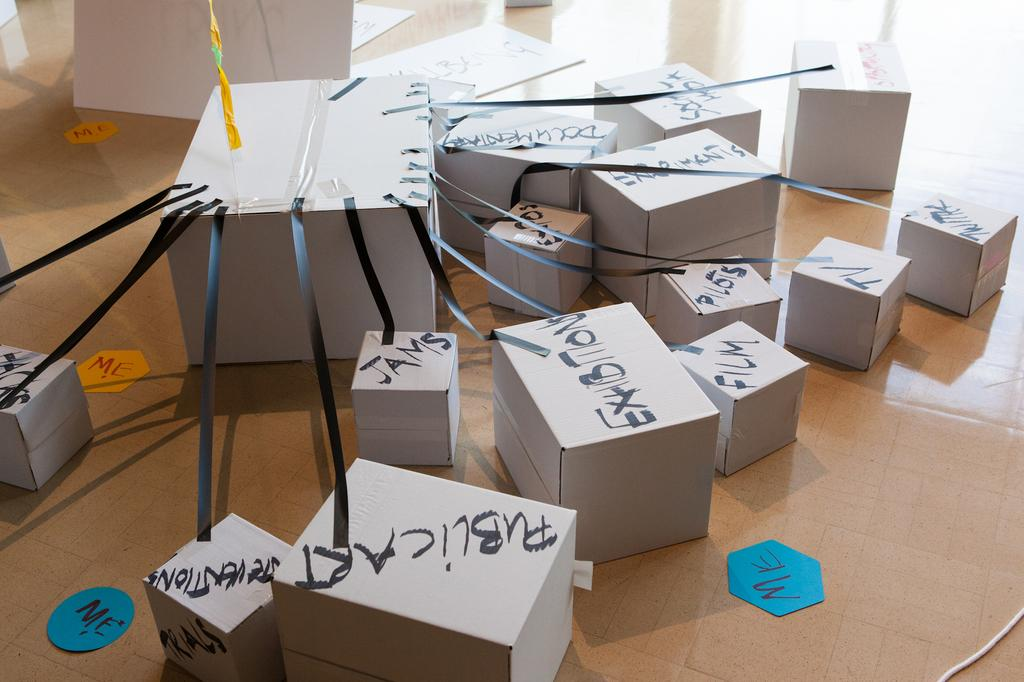<image>
Present a compact description of the photo's key features. Several boxes, including one that says JAMS, are connected to a larger box with tape. 